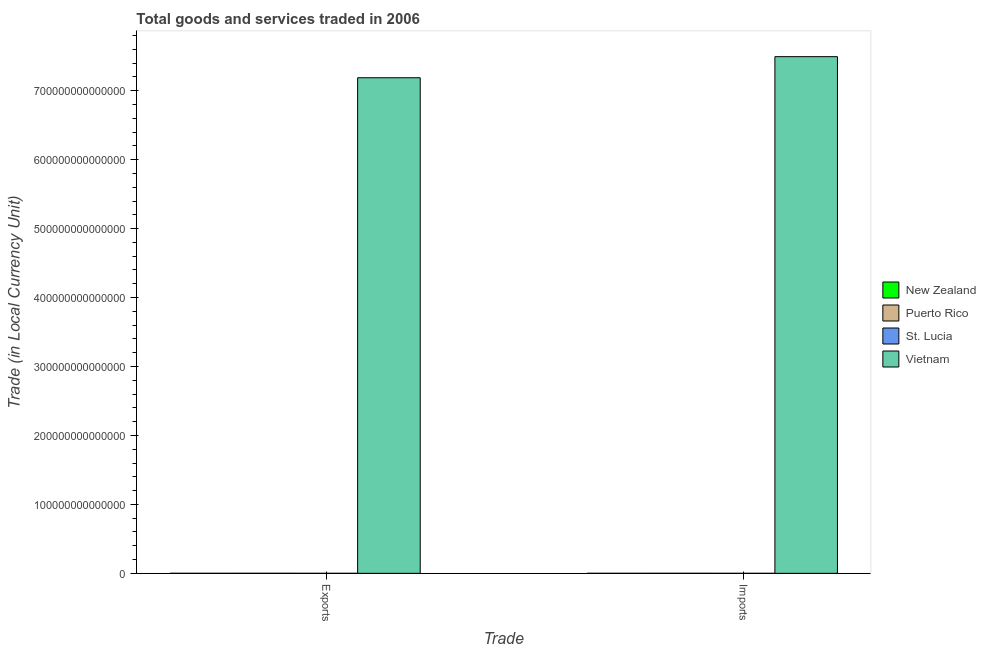Are the number of bars per tick equal to the number of legend labels?
Your answer should be very brief. Yes. How many bars are there on the 2nd tick from the left?
Keep it short and to the point. 4. What is the label of the 1st group of bars from the left?
Provide a succinct answer. Exports. What is the imports of goods and services in New Zealand?
Make the answer very short. 5.16e+1. Across all countries, what is the maximum export of goods and services?
Make the answer very short. 7.19e+14. Across all countries, what is the minimum export of goods and services?
Your response must be concise. 1.19e+09. In which country was the imports of goods and services maximum?
Keep it short and to the point. Vietnam. In which country was the imports of goods and services minimum?
Offer a very short reply. St. Lucia. What is the total export of goods and services in the graph?
Your answer should be compact. 7.19e+14. What is the difference between the export of goods and services in New Zealand and that in St. Lucia?
Offer a terse response. 4.97e+1. What is the difference between the imports of goods and services in St. Lucia and the export of goods and services in Puerto Rico?
Offer a terse response. -7.07e+1. What is the average export of goods and services per country?
Keep it short and to the point. 1.80e+14. What is the difference between the imports of goods and services and export of goods and services in Puerto Rico?
Keep it short and to the point. -1.46e+1. What is the ratio of the imports of goods and services in Vietnam to that in Puerto Rico?
Offer a terse response. 1.29e+04. What does the 1st bar from the left in Imports represents?
Provide a short and direct response. New Zealand. What does the 1st bar from the right in Imports represents?
Offer a terse response. Vietnam. How many bars are there?
Offer a terse response. 8. How many countries are there in the graph?
Provide a succinct answer. 4. What is the difference between two consecutive major ticks on the Y-axis?
Keep it short and to the point. 1.00e+14. Are the values on the major ticks of Y-axis written in scientific E-notation?
Make the answer very short. No. How many legend labels are there?
Offer a terse response. 4. What is the title of the graph?
Offer a very short reply. Total goods and services traded in 2006. What is the label or title of the X-axis?
Provide a short and direct response. Trade. What is the label or title of the Y-axis?
Make the answer very short. Trade (in Local Currency Unit). What is the Trade (in Local Currency Unit) of New Zealand in Exports?
Offer a terse response. 5.09e+1. What is the Trade (in Local Currency Unit) in Puerto Rico in Exports?
Ensure brevity in your answer.  7.26e+1. What is the Trade (in Local Currency Unit) of St. Lucia in Exports?
Your answer should be very brief. 1.19e+09. What is the Trade (in Local Currency Unit) of Vietnam in Exports?
Offer a terse response. 7.19e+14. What is the Trade (in Local Currency Unit) in New Zealand in Imports?
Offer a very short reply. 5.16e+1. What is the Trade (in Local Currency Unit) of Puerto Rico in Imports?
Keep it short and to the point. 5.80e+1. What is the Trade (in Local Currency Unit) of St. Lucia in Imports?
Give a very brief answer. 1.91e+09. What is the Trade (in Local Currency Unit) of Vietnam in Imports?
Your response must be concise. 7.49e+14. Across all Trade, what is the maximum Trade (in Local Currency Unit) of New Zealand?
Provide a succinct answer. 5.16e+1. Across all Trade, what is the maximum Trade (in Local Currency Unit) in Puerto Rico?
Keep it short and to the point. 7.26e+1. Across all Trade, what is the maximum Trade (in Local Currency Unit) in St. Lucia?
Ensure brevity in your answer.  1.91e+09. Across all Trade, what is the maximum Trade (in Local Currency Unit) of Vietnam?
Ensure brevity in your answer.  7.49e+14. Across all Trade, what is the minimum Trade (in Local Currency Unit) of New Zealand?
Your response must be concise. 5.09e+1. Across all Trade, what is the minimum Trade (in Local Currency Unit) in Puerto Rico?
Ensure brevity in your answer.  5.80e+1. Across all Trade, what is the minimum Trade (in Local Currency Unit) of St. Lucia?
Keep it short and to the point. 1.19e+09. Across all Trade, what is the minimum Trade (in Local Currency Unit) of Vietnam?
Keep it short and to the point. 7.19e+14. What is the total Trade (in Local Currency Unit) in New Zealand in the graph?
Give a very brief answer. 1.03e+11. What is the total Trade (in Local Currency Unit) of Puerto Rico in the graph?
Offer a terse response. 1.31e+11. What is the total Trade (in Local Currency Unit) in St. Lucia in the graph?
Offer a very short reply. 3.10e+09. What is the total Trade (in Local Currency Unit) in Vietnam in the graph?
Offer a very short reply. 1.47e+15. What is the difference between the Trade (in Local Currency Unit) of New Zealand in Exports and that in Imports?
Provide a short and direct response. -6.64e+08. What is the difference between the Trade (in Local Currency Unit) in Puerto Rico in Exports and that in Imports?
Keep it short and to the point. 1.46e+1. What is the difference between the Trade (in Local Currency Unit) of St. Lucia in Exports and that in Imports?
Your response must be concise. -7.19e+08. What is the difference between the Trade (in Local Currency Unit) of Vietnam in Exports and that in Imports?
Your response must be concise. -3.06e+13. What is the difference between the Trade (in Local Currency Unit) of New Zealand in Exports and the Trade (in Local Currency Unit) of Puerto Rico in Imports?
Offer a very short reply. -7.11e+09. What is the difference between the Trade (in Local Currency Unit) of New Zealand in Exports and the Trade (in Local Currency Unit) of St. Lucia in Imports?
Ensure brevity in your answer.  4.90e+1. What is the difference between the Trade (in Local Currency Unit) of New Zealand in Exports and the Trade (in Local Currency Unit) of Vietnam in Imports?
Provide a short and direct response. -7.49e+14. What is the difference between the Trade (in Local Currency Unit) of Puerto Rico in Exports and the Trade (in Local Currency Unit) of St. Lucia in Imports?
Give a very brief answer. 7.07e+1. What is the difference between the Trade (in Local Currency Unit) in Puerto Rico in Exports and the Trade (in Local Currency Unit) in Vietnam in Imports?
Keep it short and to the point. -7.49e+14. What is the difference between the Trade (in Local Currency Unit) of St. Lucia in Exports and the Trade (in Local Currency Unit) of Vietnam in Imports?
Provide a succinct answer. -7.49e+14. What is the average Trade (in Local Currency Unit) in New Zealand per Trade?
Give a very brief answer. 5.13e+1. What is the average Trade (in Local Currency Unit) in Puerto Rico per Trade?
Offer a terse response. 6.53e+1. What is the average Trade (in Local Currency Unit) of St. Lucia per Trade?
Offer a very short reply. 1.55e+09. What is the average Trade (in Local Currency Unit) in Vietnam per Trade?
Your answer should be very brief. 7.34e+14. What is the difference between the Trade (in Local Currency Unit) of New Zealand and Trade (in Local Currency Unit) of Puerto Rico in Exports?
Your response must be concise. -2.17e+1. What is the difference between the Trade (in Local Currency Unit) of New Zealand and Trade (in Local Currency Unit) of St. Lucia in Exports?
Provide a succinct answer. 4.97e+1. What is the difference between the Trade (in Local Currency Unit) of New Zealand and Trade (in Local Currency Unit) of Vietnam in Exports?
Your answer should be compact. -7.19e+14. What is the difference between the Trade (in Local Currency Unit) in Puerto Rico and Trade (in Local Currency Unit) in St. Lucia in Exports?
Provide a succinct answer. 7.14e+1. What is the difference between the Trade (in Local Currency Unit) of Puerto Rico and Trade (in Local Currency Unit) of Vietnam in Exports?
Make the answer very short. -7.19e+14. What is the difference between the Trade (in Local Currency Unit) in St. Lucia and Trade (in Local Currency Unit) in Vietnam in Exports?
Provide a short and direct response. -7.19e+14. What is the difference between the Trade (in Local Currency Unit) of New Zealand and Trade (in Local Currency Unit) of Puerto Rico in Imports?
Your response must be concise. -6.45e+09. What is the difference between the Trade (in Local Currency Unit) in New Zealand and Trade (in Local Currency Unit) in St. Lucia in Imports?
Keep it short and to the point. 4.97e+1. What is the difference between the Trade (in Local Currency Unit) of New Zealand and Trade (in Local Currency Unit) of Vietnam in Imports?
Your answer should be compact. -7.49e+14. What is the difference between the Trade (in Local Currency Unit) of Puerto Rico and Trade (in Local Currency Unit) of St. Lucia in Imports?
Your response must be concise. 5.61e+1. What is the difference between the Trade (in Local Currency Unit) of Puerto Rico and Trade (in Local Currency Unit) of Vietnam in Imports?
Your answer should be very brief. -7.49e+14. What is the difference between the Trade (in Local Currency Unit) in St. Lucia and Trade (in Local Currency Unit) in Vietnam in Imports?
Make the answer very short. -7.49e+14. What is the ratio of the Trade (in Local Currency Unit) of New Zealand in Exports to that in Imports?
Keep it short and to the point. 0.99. What is the ratio of the Trade (in Local Currency Unit) in Puerto Rico in Exports to that in Imports?
Provide a succinct answer. 1.25. What is the ratio of the Trade (in Local Currency Unit) in St. Lucia in Exports to that in Imports?
Provide a succinct answer. 0.62. What is the ratio of the Trade (in Local Currency Unit) of Vietnam in Exports to that in Imports?
Ensure brevity in your answer.  0.96. What is the difference between the highest and the second highest Trade (in Local Currency Unit) of New Zealand?
Make the answer very short. 6.64e+08. What is the difference between the highest and the second highest Trade (in Local Currency Unit) in Puerto Rico?
Your answer should be very brief. 1.46e+1. What is the difference between the highest and the second highest Trade (in Local Currency Unit) in St. Lucia?
Offer a very short reply. 7.19e+08. What is the difference between the highest and the second highest Trade (in Local Currency Unit) in Vietnam?
Your response must be concise. 3.06e+13. What is the difference between the highest and the lowest Trade (in Local Currency Unit) of New Zealand?
Offer a very short reply. 6.64e+08. What is the difference between the highest and the lowest Trade (in Local Currency Unit) in Puerto Rico?
Keep it short and to the point. 1.46e+1. What is the difference between the highest and the lowest Trade (in Local Currency Unit) in St. Lucia?
Provide a succinct answer. 7.19e+08. What is the difference between the highest and the lowest Trade (in Local Currency Unit) in Vietnam?
Keep it short and to the point. 3.06e+13. 